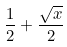<formula> <loc_0><loc_0><loc_500><loc_500>\frac { 1 } { 2 } + \frac { \sqrt { x } } { 2 }</formula> 